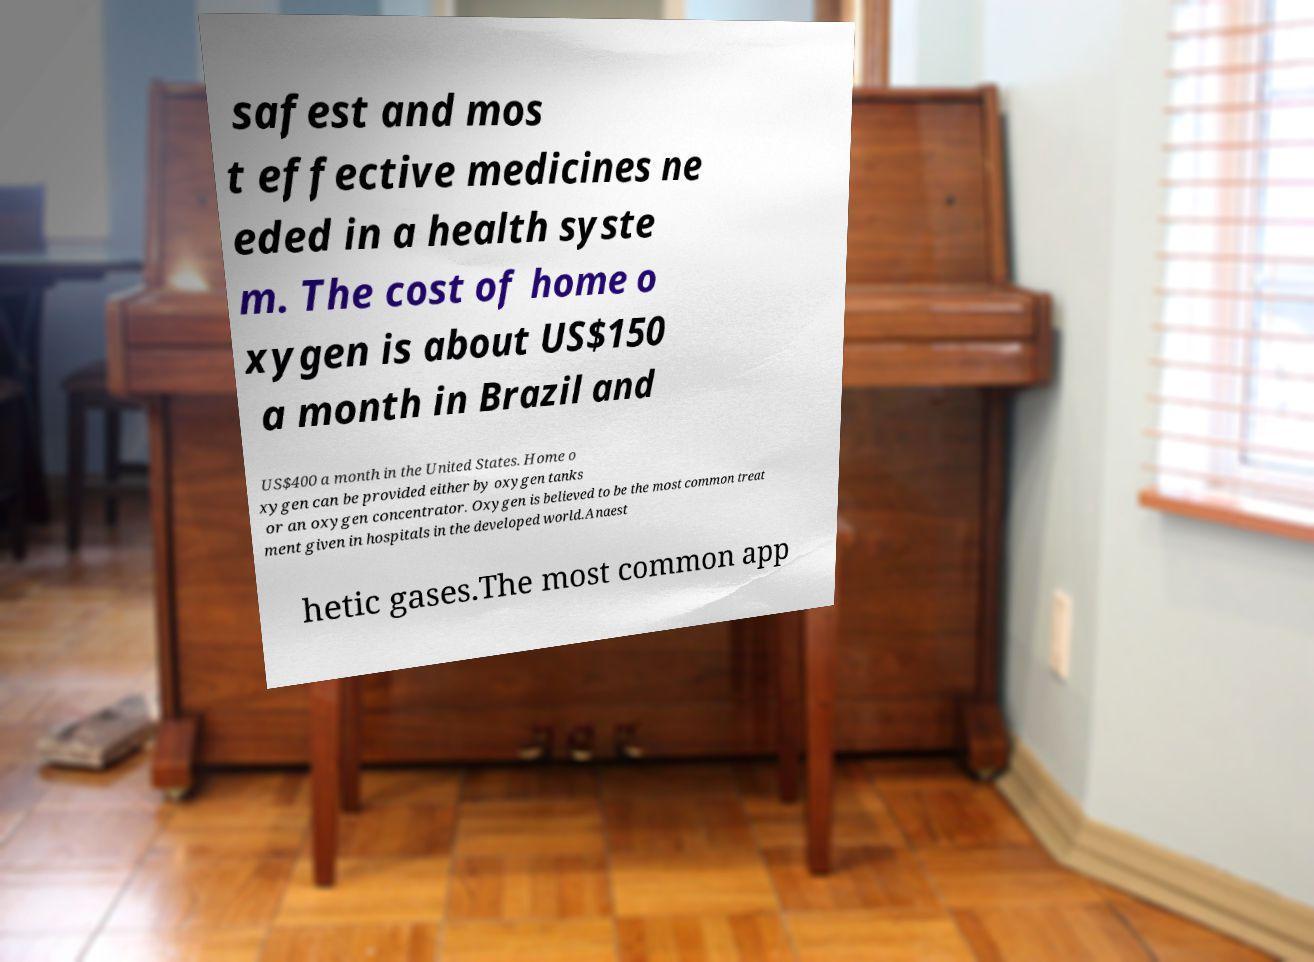For documentation purposes, I need the text within this image transcribed. Could you provide that? safest and mos t effective medicines ne eded in a health syste m. The cost of home o xygen is about US$150 a month in Brazil and US$400 a month in the United States. Home o xygen can be provided either by oxygen tanks or an oxygen concentrator. Oxygen is believed to be the most common treat ment given in hospitals in the developed world.Anaest hetic gases.The most common app 